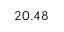<formula> <loc_0><loc_0><loc_500><loc_500>2 0 . 4 8</formula> 